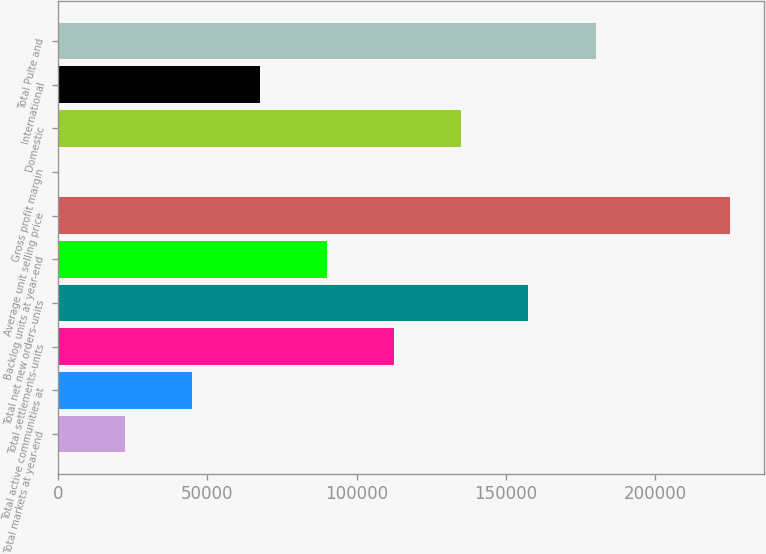Convert chart to OTSL. <chart><loc_0><loc_0><loc_500><loc_500><bar_chart><fcel>Total markets at year-end<fcel>Total active communities at<fcel>Total settlements-units<fcel>Total net new orders-units<fcel>Backlog units at year-end<fcel>Average unit selling price<fcel>Gross profit margin<fcel>Domestic<fcel>International<fcel>Total Pulte and<nl><fcel>22518<fcel>45016<fcel>112510<fcel>157506<fcel>90012<fcel>225000<fcel>20<fcel>135008<fcel>67514<fcel>180004<nl></chart> 